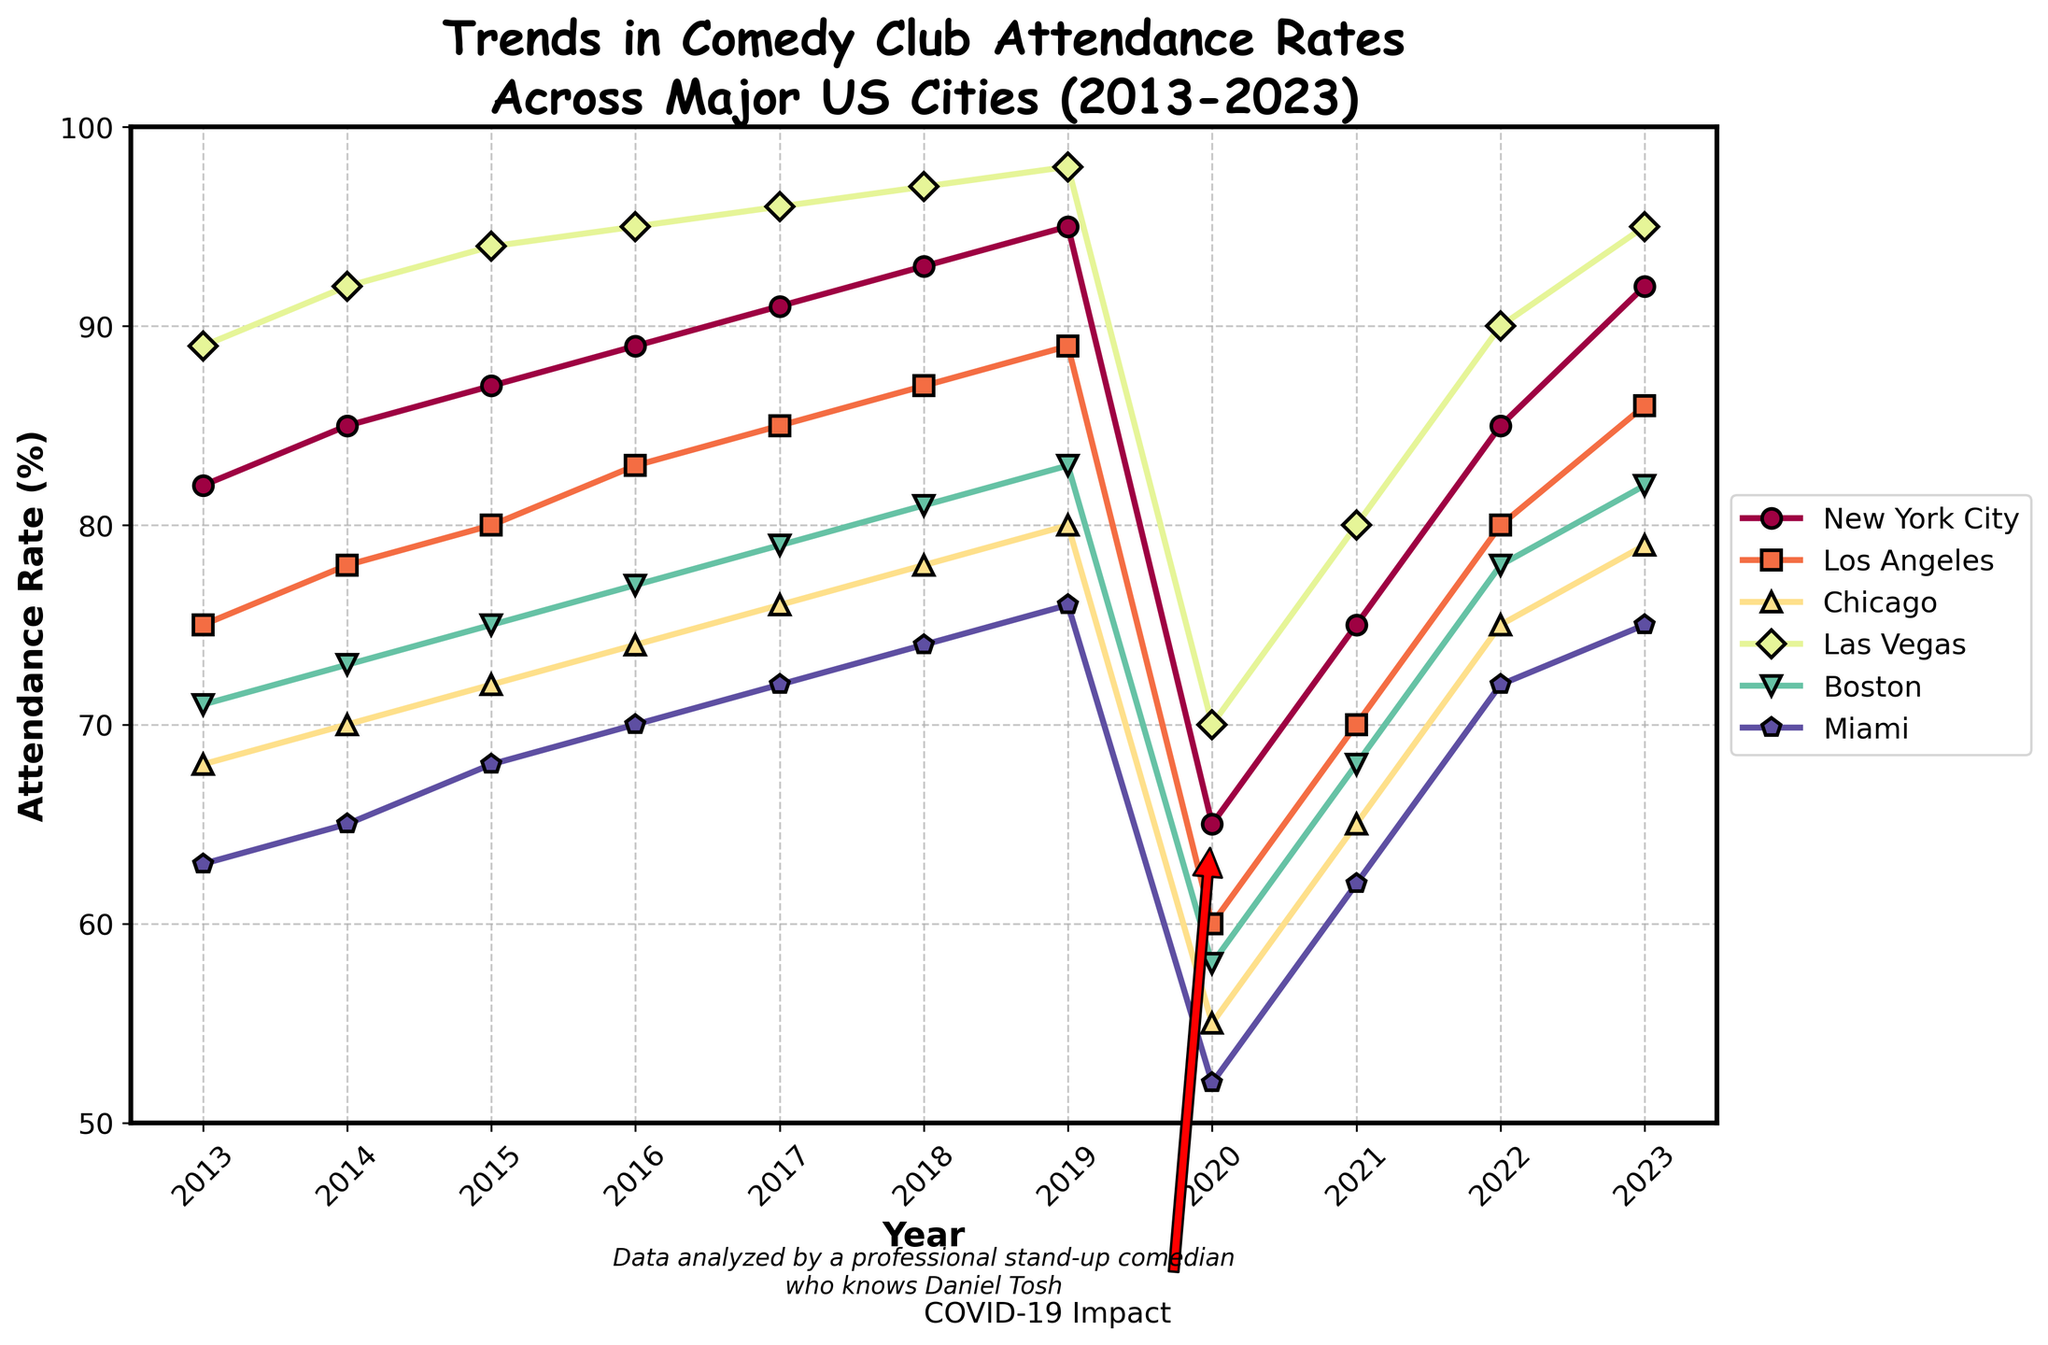What year did New York City and Los Angeles have the closest attendance rates? The two cities had the closest attendance rates in 2023. New York City had 92%, and Los Angeles had 86%, with a difference of 6%.
Answer: 2023 What is the overall trend of attendance rates in comedy clubs in Las Vegas from 2013 to 2023? The attendance rate in Las Vegas increased steadily from 2013 to 2019, dropped significantly in 2020 due to the pandemic, and then recovered in the following years but did not reach pre-pandemic levels.
Answer: Increased, dropped in 2020, then partially recovered How did the COVID-19 pandemic in 2020 affect the attendance rates across all cities? In 2020, all cities experienced a significant drop in attendance rates. This can be observed as a sharp dip in the trend lines for all cities in that year.
Answer: Significant decrease Which city had the highest attendance rate in 2016? In 2016, Las Vegas had the highest attendance rate with 95%.
Answer: Las Vegas Compare the trend lines for Miami and Chicago. Did Miami's attendance rate ever exceed Chicago's? Miami's attendance rate never exceeded Chicago's. Chicago consistently had higher attendance rates compared to Miami throughout the decade.
Answer: No Which city showed the most significant recovery in attendance rates after the COVID-19 pandemic? New York City showed the most significant recovery, reaching an attendance rate of 92% in 2023, which is close to its pre-pandemic level.
Answer: New York City Compare the average attendance rates for cities on the East Coast (New York City, Boston, Miami) before and after the pandemic (2013-2019 vs. 2021-2023). Before the pandemic (2013-2019), the average attendance rate for East Coast cities was (82+85+87+89+91+93+95)/7 + (71+73+75+77+79+81+83)/7 + (63+65+68+70+72+74+76)/7 = 85.41. After the pandemic (2021-2023), the average rate was (75+85+92)/3 + (68+78+82)/3 + (62+72+75)/3 = 77.78.
Answer: 85.41 before, 77.78 after Find the two cities with the most and least steep decline in attendance rates in 2020 compared to 2019. Las Vegas had the least steep decline from 98% to 70% (28%), and Chicago had the most steep decline from 80% to 55% (25%).
Answer: Las Vegas (least), Chicago (most) How did Boston's attendance rate change from 2017 to 2023? Boston's attendance rate increased steadily from 79% in 2017 to 83% in 2019, dropped to 58% in 2020, and then bounced back to 82% by 2023.
Answer: Rose, fell in 2020, then rose again What was the difference between the highest and lowest attendance rates in 2023? In 2023, the highest attendance rate was 95% (Las Vegas), and the lowest was 75% (Miami), making the difference 20%.
Answer: 20% 